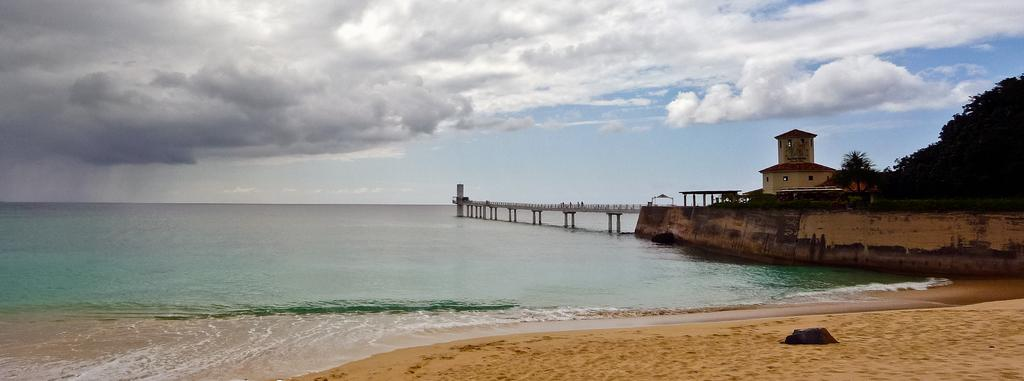What type of structure is present in the image? There is a house with a roof and windows in the image. What natural elements can be seen in the image? There are trees, plants, grass, and clouds visible in the image. What architectural features are present in the image? There is a bridge with pillars and a tower on the water in the image. How many dogs are sitting on the roof of the house in the image? There are no dogs present in the image; it only features a house, trees, plants, grass, a bridge, a tower, and clouds. 